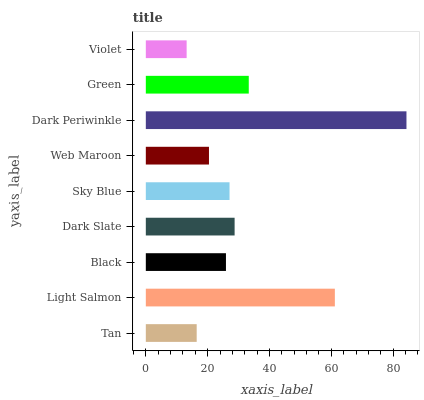Is Violet the minimum?
Answer yes or no. Yes. Is Dark Periwinkle the maximum?
Answer yes or no. Yes. Is Light Salmon the minimum?
Answer yes or no. No. Is Light Salmon the maximum?
Answer yes or no. No. Is Light Salmon greater than Tan?
Answer yes or no. Yes. Is Tan less than Light Salmon?
Answer yes or no. Yes. Is Tan greater than Light Salmon?
Answer yes or no. No. Is Light Salmon less than Tan?
Answer yes or no. No. Is Sky Blue the high median?
Answer yes or no. Yes. Is Sky Blue the low median?
Answer yes or no. Yes. Is Web Maroon the high median?
Answer yes or no. No. Is Light Salmon the low median?
Answer yes or no. No. 